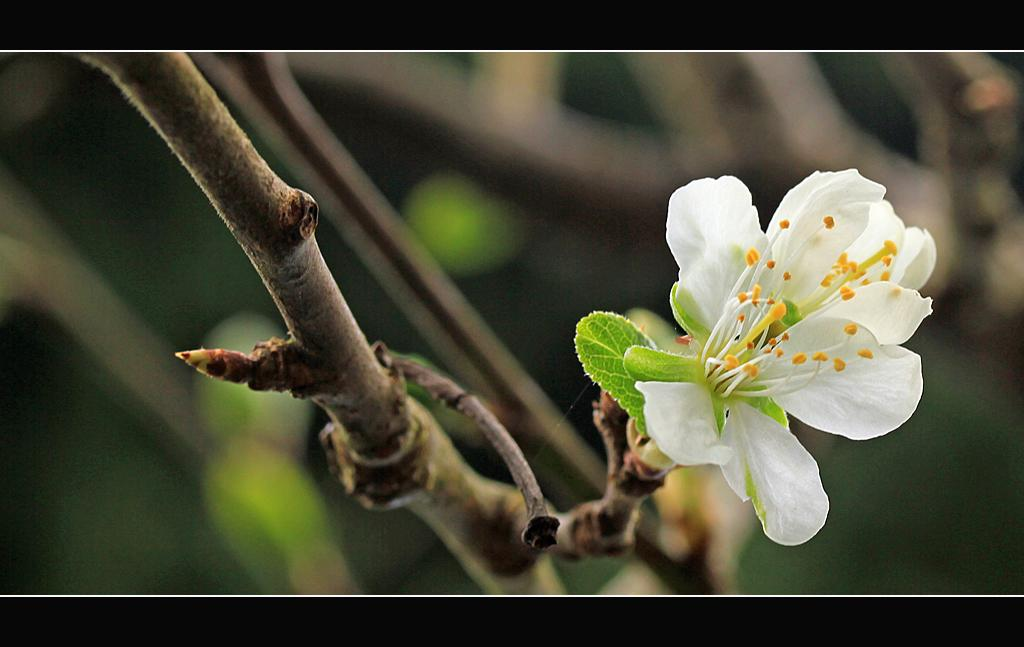What is attached to the stem in the image? There is a flower on the stem in the image. What else can be seen on the stem besides the flower? There are leaves on the stem in the image. How many legs can be seen supporting the stem in the image? There are no legs visible in the image; the stem is likely supported by a plant or tree. 